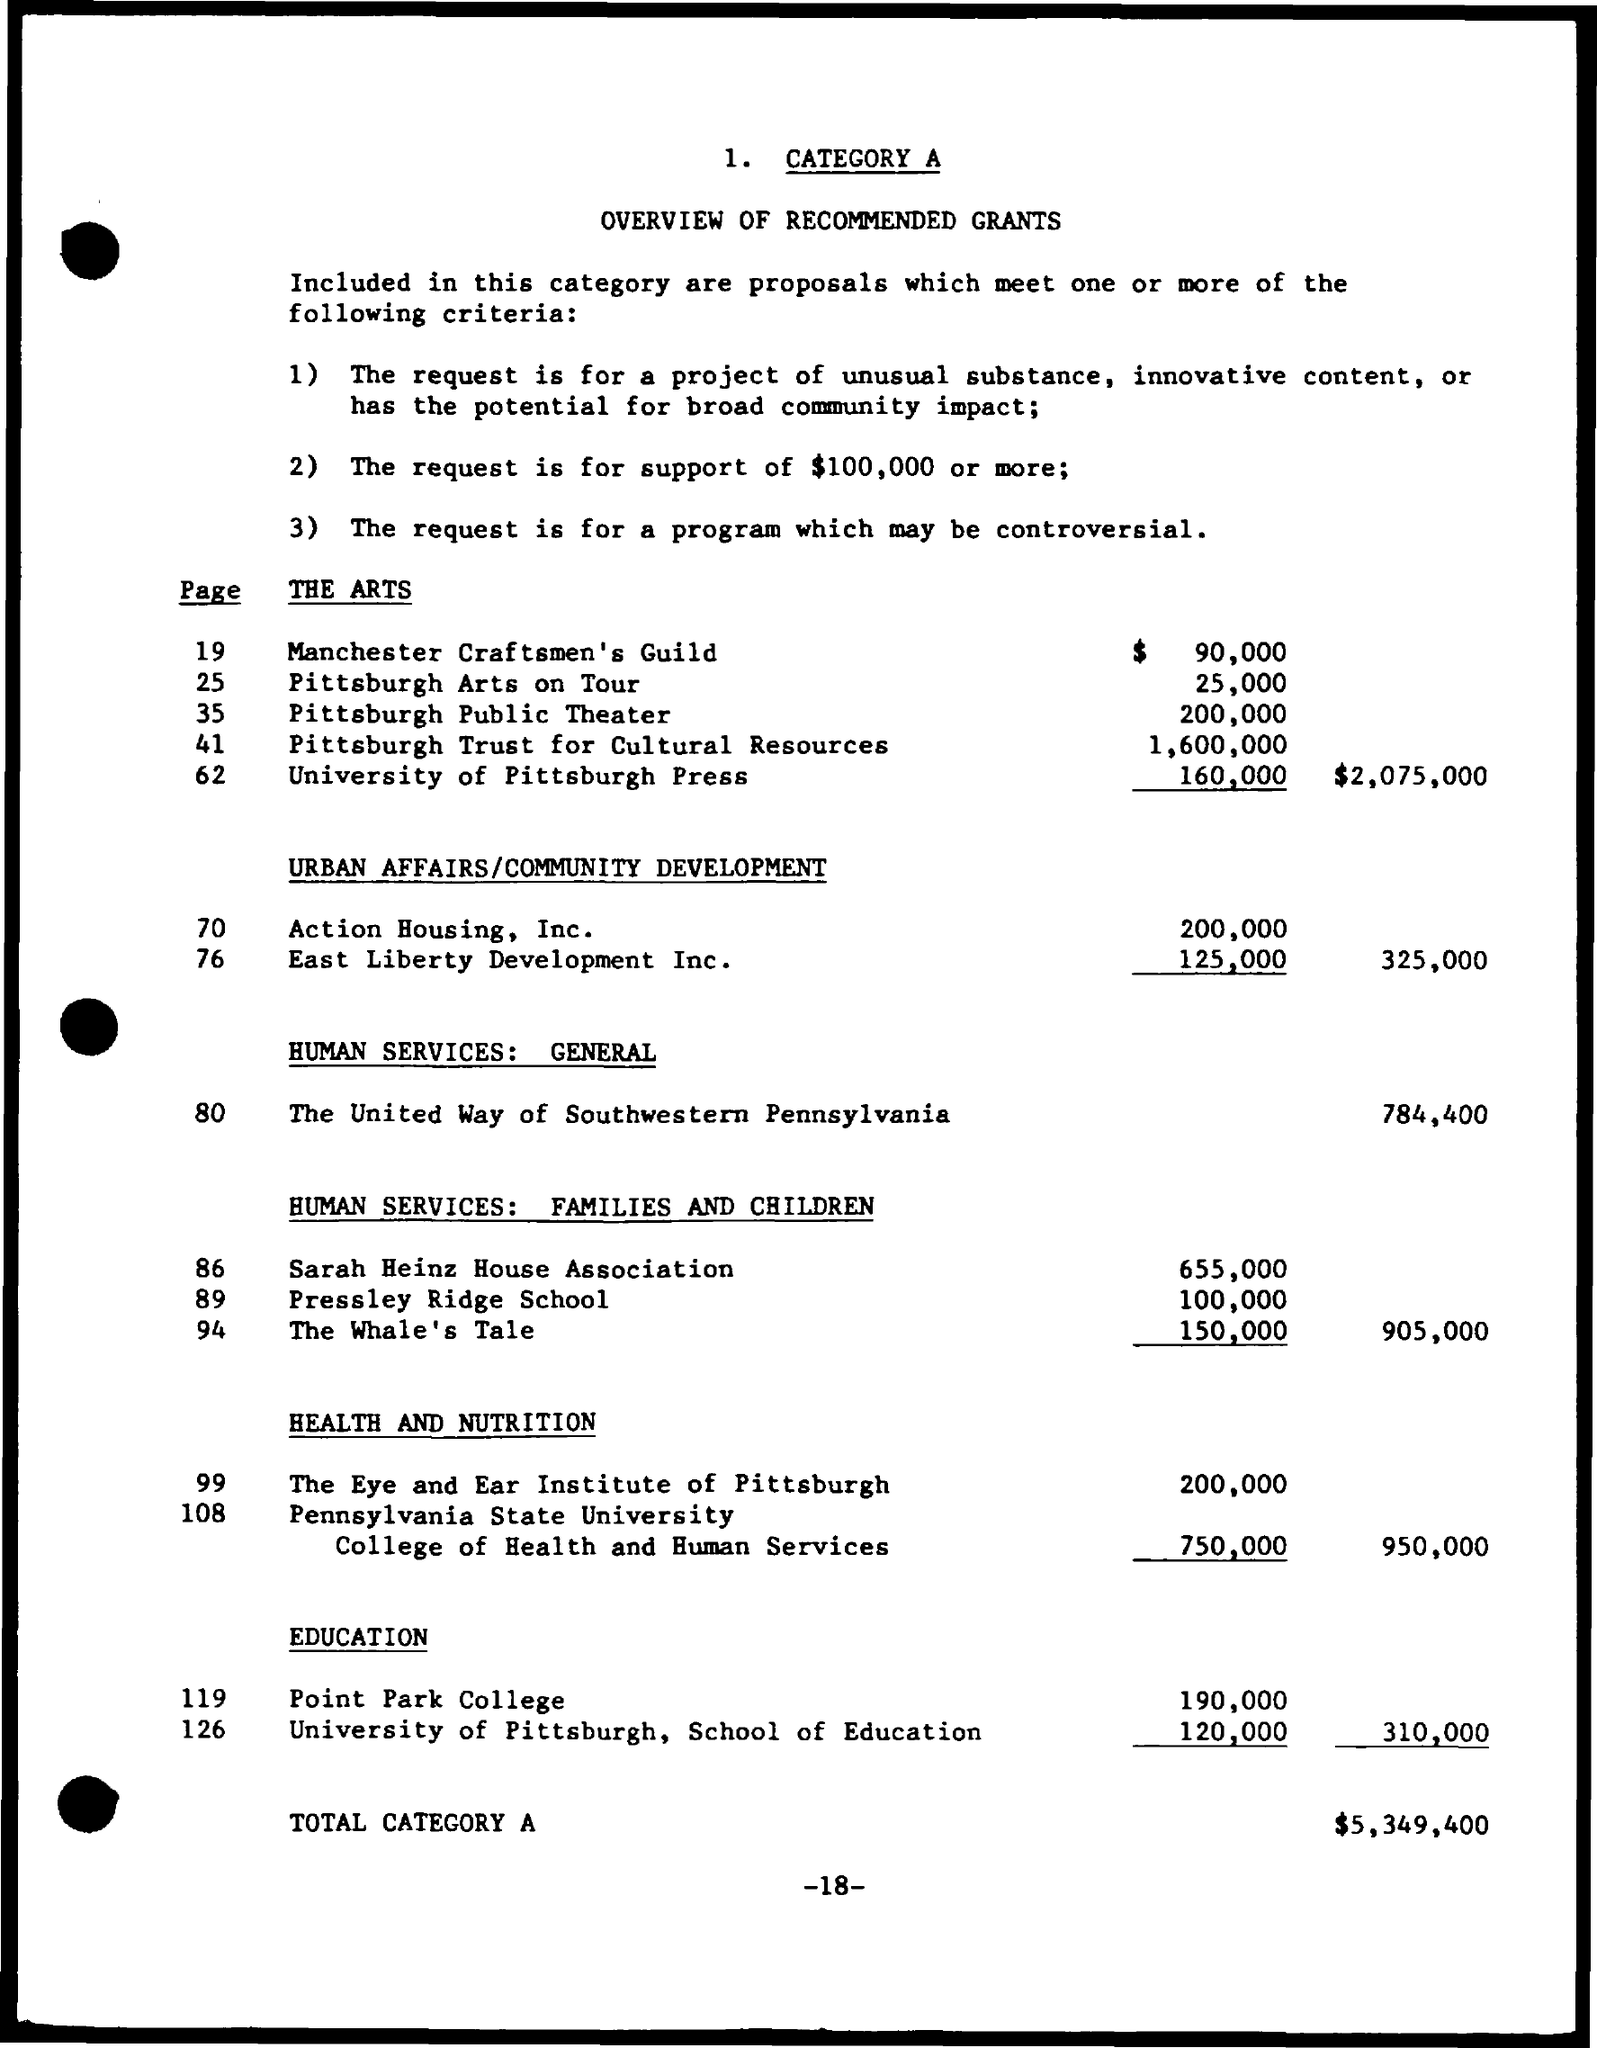What is the page number?
Offer a terse response. -18-. 